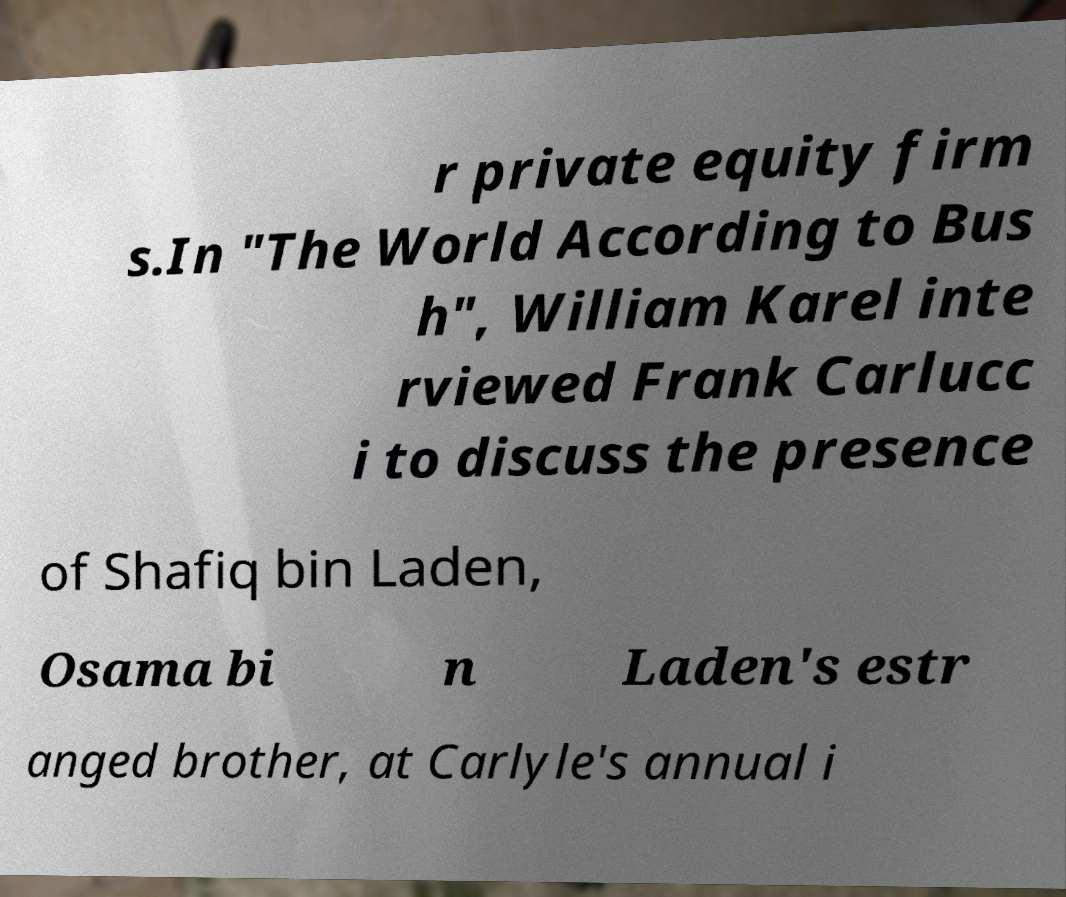What messages or text are displayed in this image? I need them in a readable, typed format. r private equity firm s.In "The World According to Bus h", William Karel inte rviewed Frank Carlucc i to discuss the presence of Shafiq bin Laden, Osama bi n Laden's estr anged brother, at Carlyle's annual i 